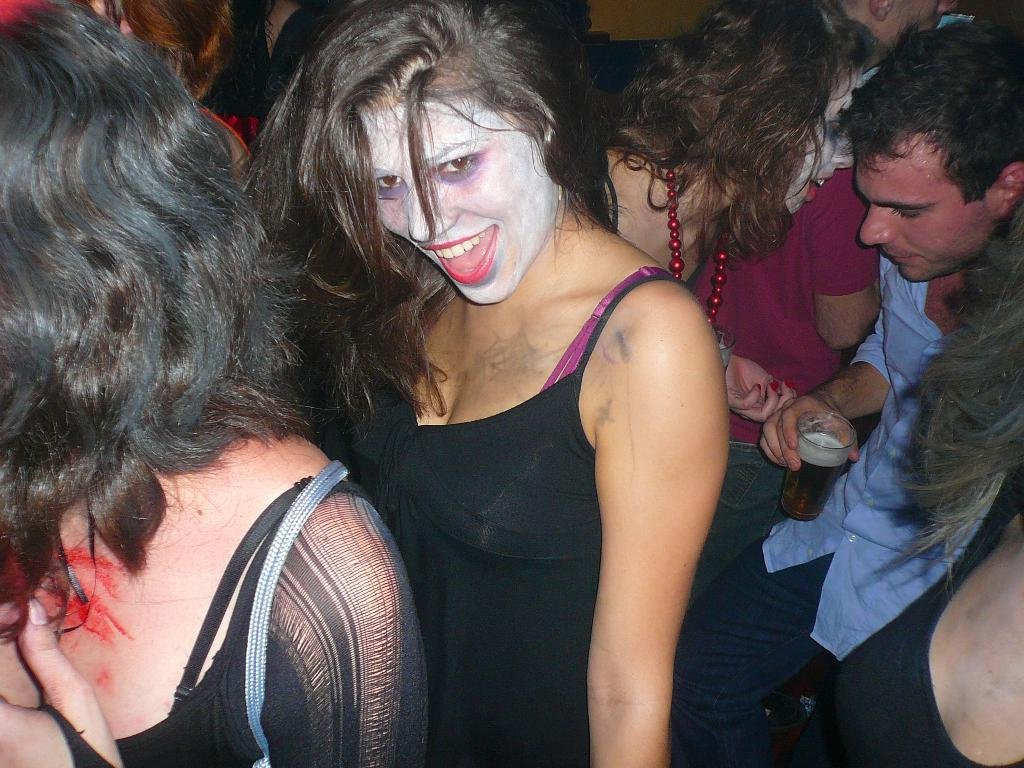What is the main subject of the image? The main subject of the image is a group of persons. What is a notable feature of the persons in the image? The persons have painted faces. Can you describe the position of the person on the right side of the image? The person on the right side is standing. What is the person on the right side holding? The person on the right side is holding a glass. What is inside the glass? There is a drink in the glass. What type of whip is being used by the person on the left side of the image? There is no whip present in the image; the persons have painted faces and are not holding any whips. 